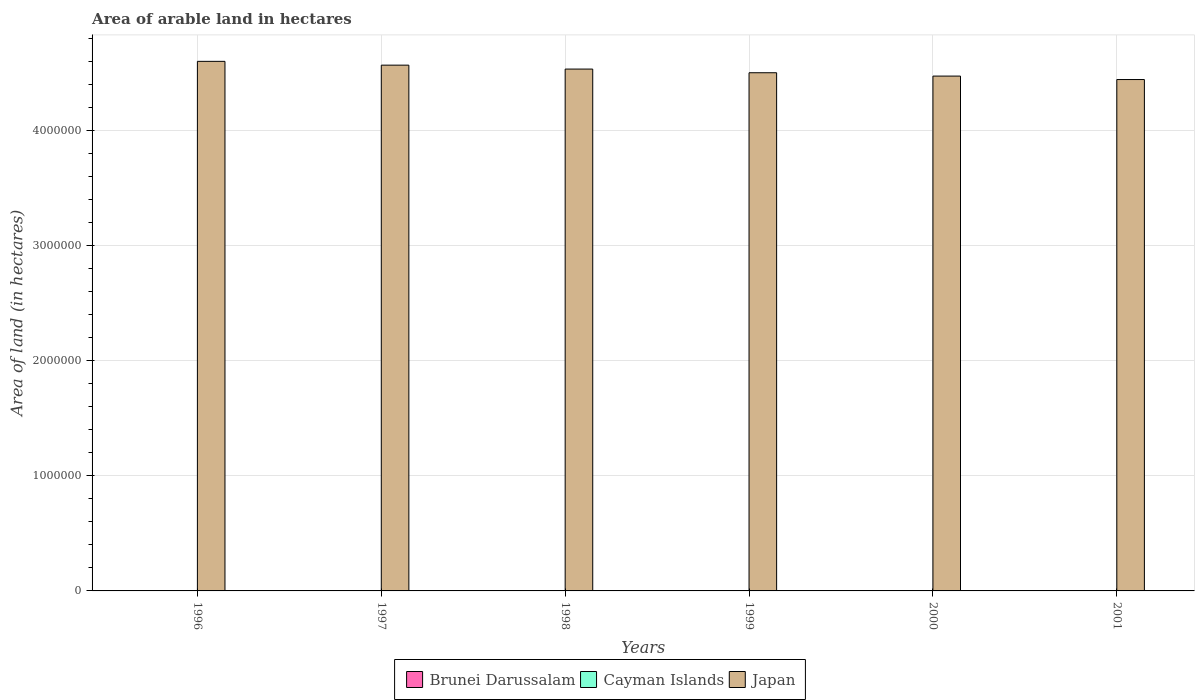How many different coloured bars are there?
Offer a very short reply. 3. How many bars are there on the 5th tick from the left?
Your response must be concise. 3. What is the total arable land in Cayman Islands in 2001?
Ensure brevity in your answer.  200. Across all years, what is the minimum total arable land in Brunei Darussalam?
Your response must be concise. 2000. What is the total total arable land in Cayman Islands in the graph?
Offer a very short reply. 1200. What is the difference between the total arable land in Brunei Darussalam in 1996 and that in 1997?
Your response must be concise. 0. What is the difference between the total arable land in Japan in 2000 and the total arable land in Cayman Islands in 1998?
Provide a succinct answer. 4.47e+06. In the year 1998, what is the difference between the total arable land in Japan and total arable land in Cayman Islands?
Offer a terse response. 4.53e+06. Is the total arable land in Brunei Darussalam in 1999 less than that in 2000?
Provide a short and direct response. No. What is the difference between the highest and the second highest total arable land in Cayman Islands?
Offer a very short reply. 0. What is the difference between the highest and the lowest total arable land in Japan?
Offer a very short reply. 1.58e+05. In how many years, is the total arable land in Brunei Darussalam greater than the average total arable land in Brunei Darussalam taken over all years?
Provide a short and direct response. 0. Is the sum of the total arable land in Brunei Darussalam in 1996 and 1997 greater than the maximum total arable land in Japan across all years?
Provide a short and direct response. No. What does the 1st bar from the left in 1998 represents?
Your answer should be compact. Brunei Darussalam. What does the 3rd bar from the right in 2001 represents?
Your response must be concise. Brunei Darussalam. Is it the case that in every year, the sum of the total arable land in Cayman Islands and total arable land in Brunei Darussalam is greater than the total arable land in Japan?
Keep it short and to the point. No. How many bars are there?
Your answer should be very brief. 18. What is the difference between two consecutive major ticks on the Y-axis?
Your answer should be compact. 1.00e+06. Does the graph contain any zero values?
Give a very brief answer. No. Does the graph contain grids?
Provide a succinct answer. Yes. Where does the legend appear in the graph?
Make the answer very short. Bottom center. How many legend labels are there?
Ensure brevity in your answer.  3. How are the legend labels stacked?
Your answer should be very brief. Horizontal. What is the title of the graph?
Your response must be concise. Area of arable land in hectares. What is the label or title of the X-axis?
Provide a succinct answer. Years. What is the label or title of the Y-axis?
Offer a terse response. Area of land (in hectares). What is the Area of land (in hectares) in Cayman Islands in 1996?
Make the answer very short. 200. What is the Area of land (in hectares) in Japan in 1996?
Offer a terse response. 4.60e+06. What is the Area of land (in hectares) of Brunei Darussalam in 1997?
Give a very brief answer. 2000. What is the Area of land (in hectares) of Cayman Islands in 1997?
Offer a terse response. 200. What is the Area of land (in hectares) of Japan in 1997?
Your response must be concise. 4.57e+06. What is the Area of land (in hectares) of Cayman Islands in 1998?
Offer a terse response. 200. What is the Area of land (in hectares) of Japan in 1998?
Your answer should be compact. 4.54e+06. What is the Area of land (in hectares) in Japan in 1999?
Offer a terse response. 4.50e+06. What is the Area of land (in hectares) in Cayman Islands in 2000?
Your answer should be compact. 200. What is the Area of land (in hectares) of Japan in 2000?
Ensure brevity in your answer.  4.47e+06. What is the Area of land (in hectares) of Brunei Darussalam in 2001?
Provide a succinct answer. 2000. What is the Area of land (in hectares) of Japan in 2001?
Your response must be concise. 4.44e+06. Across all years, what is the maximum Area of land (in hectares) in Brunei Darussalam?
Offer a terse response. 2000. Across all years, what is the maximum Area of land (in hectares) in Japan?
Offer a terse response. 4.60e+06. Across all years, what is the minimum Area of land (in hectares) in Brunei Darussalam?
Provide a succinct answer. 2000. Across all years, what is the minimum Area of land (in hectares) of Japan?
Your answer should be very brief. 4.44e+06. What is the total Area of land (in hectares) of Brunei Darussalam in the graph?
Make the answer very short. 1.20e+04. What is the total Area of land (in hectares) in Cayman Islands in the graph?
Provide a short and direct response. 1200. What is the total Area of land (in hectares) of Japan in the graph?
Keep it short and to the point. 2.71e+07. What is the difference between the Area of land (in hectares) of Japan in 1996 and that in 1997?
Your response must be concise. 3.30e+04. What is the difference between the Area of land (in hectares) in Japan in 1996 and that in 1998?
Provide a short and direct response. 6.70e+04. What is the difference between the Area of land (in hectares) of Brunei Darussalam in 1996 and that in 1999?
Offer a very short reply. 0. What is the difference between the Area of land (in hectares) of Japan in 1996 and that in 1999?
Give a very brief answer. 9.90e+04. What is the difference between the Area of land (in hectares) in Brunei Darussalam in 1996 and that in 2000?
Keep it short and to the point. 0. What is the difference between the Area of land (in hectares) of Cayman Islands in 1996 and that in 2000?
Make the answer very short. 0. What is the difference between the Area of land (in hectares) of Japan in 1996 and that in 2000?
Your answer should be very brief. 1.28e+05. What is the difference between the Area of land (in hectares) in Brunei Darussalam in 1996 and that in 2001?
Keep it short and to the point. 0. What is the difference between the Area of land (in hectares) in Japan in 1996 and that in 2001?
Provide a short and direct response. 1.58e+05. What is the difference between the Area of land (in hectares) of Japan in 1997 and that in 1998?
Give a very brief answer. 3.40e+04. What is the difference between the Area of land (in hectares) in Japan in 1997 and that in 1999?
Offer a very short reply. 6.60e+04. What is the difference between the Area of land (in hectares) in Brunei Darussalam in 1997 and that in 2000?
Keep it short and to the point. 0. What is the difference between the Area of land (in hectares) in Japan in 1997 and that in 2000?
Your answer should be compact. 9.50e+04. What is the difference between the Area of land (in hectares) of Brunei Darussalam in 1997 and that in 2001?
Your answer should be compact. 0. What is the difference between the Area of land (in hectares) in Japan in 1997 and that in 2001?
Provide a succinct answer. 1.25e+05. What is the difference between the Area of land (in hectares) of Japan in 1998 and that in 1999?
Your response must be concise. 3.20e+04. What is the difference between the Area of land (in hectares) in Cayman Islands in 1998 and that in 2000?
Your response must be concise. 0. What is the difference between the Area of land (in hectares) of Japan in 1998 and that in 2000?
Your answer should be very brief. 6.10e+04. What is the difference between the Area of land (in hectares) in Brunei Darussalam in 1998 and that in 2001?
Ensure brevity in your answer.  0. What is the difference between the Area of land (in hectares) in Cayman Islands in 1998 and that in 2001?
Your response must be concise. 0. What is the difference between the Area of land (in hectares) in Japan in 1998 and that in 2001?
Offer a very short reply. 9.10e+04. What is the difference between the Area of land (in hectares) in Brunei Darussalam in 1999 and that in 2000?
Give a very brief answer. 0. What is the difference between the Area of land (in hectares) in Cayman Islands in 1999 and that in 2000?
Your response must be concise. 0. What is the difference between the Area of land (in hectares) in Japan in 1999 and that in 2000?
Make the answer very short. 2.90e+04. What is the difference between the Area of land (in hectares) in Cayman Islands in 1999 and that in 2001?
Your answer should be compact. 0. What is the difference between the Area of land (in hectares) of Japan in 1999 and that in 2001?
Provide a succinct answer. 5.90e+04. What is the difference between the Area of land (in hectares) in Brunei Darussalam in 2000 and that in 2001?
Your answer should be very brief. 0. What is the difference between the Area of land (in hectares) of Brunei Darussalam in 1996 and the Area of land (in hectares) of Cayman Islands in 1997?
Provide a short and direct response. 1800. What is the difference between the Area of land (in hectares) of Brunei Darussalam in 1996 and the Area of land (in hectares) of Japan in 1997?
Offer a terse response. -4.57e+06. What is the difference between the Area of land (in hectares) of Cayman Islands in 1996 and the Area of land (in hectares) of Japan in 1997?
Provide a short and direct response. -4.57e+06. What is the difference between the Area of land (in hectares) in Brunei Darussalam in 1996 and the Area of land (in hectares) in Cayman Islands in 1998?
Your response must be concise. 1800. What is the difference between the Area of land (in hectares) of Brunei Darussalam in 1996 and the Area of land (in hectares) of Japan in 1998?
Keep it short and to the point. -4.53e+06. What is the difference between the Area of land (in hectares) of Cayman Islands in 1996 and the Area of land (in hectares) of Japan in 1998?
Offer a very short reply. -4.53e+06. What is the difference between the Area of land (in hectares) in Brunei Darussalam in 1996 and the Area of land (in hectares) in Cayman Islands in 1999?
Keep it short and to the point. 1800. What is the difference between the Area of land (in hectares) in Brunei Darussalam in 1996 and the Area of land (in hectares) in Japan in 1999?
Your answer should be compact. -4.50e+06. What is the difference between the Area of land (in hectares) in Cayman Islands in 1996 and the Area of land (in hectares) in Japan in 1999?
Provide a succinct answer. -4.50e+06. What is the difference between the Area of land (in hectares) of Brunei Darussalam in 1996 and the Area of land (in hectares) of Cayman Islands in 2000?
Ensure brevity in your answer.  1800. What is the difference between the Area of land (in hectares) of Brunei Darussalam in 1996 and the Area of land (in hectares) of Japan in 2000?
Offer a very short reply. -4.47e+06. What is the difference between the Area of land (in hectares) in Cayman Islands in 1996 and the Area of land (in hectares) in Japan in 2000?
Your response must be concise. -4.47e+06. What is the difference between the Area of land (in hectares) in Brunei Darussalam in 1996 and the Area of land (in hectares) in Cayman Islands in 2001?
Provide a succinct answer. 1800. What is the difference between the Area of land (in hectares) in Brunei Darussalam in 1996 and the Area of land (in hectares) in Japan in 2001?
Provide a short and direct response. -4.44e+06. What is the difference between the Area of land (in hectares) in Cayman Islands in 1996 and the Area of land (in hectares) in Japan in 2001?
Ensure brevity in your answer.  -4.44e+06. What is the difference between the Area of land (in hectares) in Brunei Darussalam in 1997 and the Area of land (in hectares) in Cayman Islands in 1998?
Give a very brief answer. 1800. What is the difference between the Area of land (in hectares) of Brunei Darussalam in 1997 and the Area of land (in hectares) of Japan in 1998?
Your answer should be very brief. -4.53e+06. What is the difference between the Area of land (in hectares) of Cayman Islands in 1997 and the Area of land (in hectares) of Japan in 1998?
Provide a succinct answer. -4.53e+06. What is the difference between the Area of land (in hectares) of Brunei Darussalam in 1997 and the Area of land (in hectares) of Cayman Islands in 1999?
Keep it short and to the point. 1800. What is the difference between the Area of land (in hectares) of Brunei Darussalam in 1997 and the Area of land (in hectares) of Japan in 1999?
Offer a terse response. -4.50e+06. What is the difference between the Area of land (in hectares) of Cayman Islands in 1997 and the Area of land (in hectares) of Japan in 1999?
Make the answer very short. -4.50e+06. What is the difference between the Area of land (in hectares) of Brunei Darussalam in 1997 and the Area of land (in hectares) of Cayman Islands in 2000?
Offer a terse response. 1800. What is the difference between the Area of land (in hectares) of Brunei Darussalam in 1997 and the Area of land (in hectares) of Japan in 2000?
Your response must be concise. -4.47e+06. What is the difference between the Area of land (in hectares) of Cayman Islands in 1997 and the Area of land (in hectares) of Japan in 2000?
Keep it short and to the point. -4.47e+06. What is the difference between the Area of land (in hectares) of Brunei Darussalam in 1997 and the Area of land (in hectares) of Cayman Islands in 2001?
Give a very brief answer. 1800. What is the difference between the Area of land (in hectares) in Brunei Darussalam in 1997 and the Area of land (in hectares) in Japan in 2001?
Offer a terse response. -4.44e+06. What is the difference between the Area of land (in hectares) in Cayman Islands in 1997 and the Area of land (in hectares) in Japan in 2001?
Ensure brevity in your answer.  -4.44e+06. What is the difference between the Area of land (in hectares) of Brunei Darussalam in 1998 and the Area of land (in hectares) of Cayman Islands in 1999?
Give a very brief answer. 1800. What is the difference between the Area of land (in hectares) of Brunei Darussalam in 1998 and the Area of land (in hectares) of Japan in 1999?
Offer a terse response. -4.50e+06. What is the difference between the Area of land (in hectares) of Cayman Islands in 1998 and the Area of land (in hectares) of Japan in 1999?
Keep it short and to the point. -4.50e+06. What is the difference between the Area of land (in hectares) in Brunei Darussalam in 1998 and the Area of land (in hectares) in Cayman Islands in 2000?
Provide a succinct answer. 1800. What is the difference between the Area of land (in hectares) of Brunei Darussalam in 1998 and the Area of land (in hectares) of Japan in 2000?
Give a very brief answer. -4.47e+06. What is the difference between the Area of land (in hectares) in Cayman Islands in 1998 and the Area of land (in hectares) in Japan in 2000?
Your answer should be very brief. -4.47e+06. What is the difference between the Area of land (in hectares) in Brunei Darussalam in 1998 and the Area of land (in hectares) in Cayman Islands in 2001?
Your answer should be compact. 1800. What is the difference between the Area of land (in hectares) in Brunei Darussalam in 1998 and the Area of land (in hectares) in Japan in 2001?
Provide a short and direct response. -4.44e+06. What is the difference between the Area of land (in hectares) in Cayman Islands in 1998 and the Area of land (in hectares) in Japan in 2001?
Give a very brief answer. -4.44e+06. What is the difference between the Area of land (in hectares) in Brunei Darussalam in 1999 and the Area of land (in hectares) in Cayman Islands in 2000?
Offer a very short reply. 1800. What is the difference between the Area of land (in hectares) in Brunei Darussalam in 1999 and the Area of land (in hectares) in Japan in 2000?
Give a very brief answer. -4.47e+06. What is the difference between the Area of land (in hectares) of Cayman Islands in 1999 and the Area of land (in hectares) of Japan in 2000?
Your answer should be compact. -4.47e+06. What is the difference between the Area of land (in hectares) in Brunei Darussalam in 1999 and the Area of land (in hectares) in Cayman Islands in 2001?
Give a very brief answer. 1800. What is the difference between the Area of land (in hectares) in Brunei Darussalam in 1999 and the Area of land (in hectares) in Japan in 2001?
Give a very brief answer. -4.44e+06. What is the difference between the Area of land (in hectares) of Cayman Islands in 1999 and the Area of land (in hectares) of Japan in 2001?
Give a very brief answer. -4.44e+06. What is the difference between the Area of land (in hectares) in Brunei Darussalam in 2000 and the Area of land (in hectares) in Cayman Islands in 2001?
Offer a terse response. 1800. What is the difference between the Area of land (in hectares) of Brunei Darussalam in 2000 and the Area of land (in hectares) of Japan in 2001?
Make the answer very short. -4.44e+06. What is the difference between the Area of land (in hectares) in Cayman Islands in 2000 and the Area of land (in hectares) in Japan in 2001?
Provide a short and direct response. -4.44e+06. What is the average Area of land (in hectares) in Brunei Darussalam per year?
Give a very brief answer. 2000. What is the average Area of land (in hectares) in Cayman Islands per year?
Provide a short and direct response. 200. What is the average Area of land (in hectares) in Japan per year?
Provide a succinct answer. 4.52e+06. In the year 1996, what is the difference between the Area of land (in hectares) in Brunei Darussalam and Area of land (in hectares) in Cayman Islands?
Give a very brief answer. 1800. In the year 1996, what is the difference between the Area of land (in hectares) in Brunei Darussalam and Area of land (in hectares) in Japan?
Your response must be concise. -4.60e+06. In the year 1996, what is the difference between the Area of land (in hectares) in Cayman Islands and Area of land (in hectares) in Japan?
Offer a very short reply. -4.60e+06. In the year 1997, what is the difference between the Area of land (in hectares) in Brunei Darussalam and Area of land (in hectares) in Cayman Islands?
Your response must be concise. 1800. In the year 1997, what is the difference between the Area of land (in hectares) of Brunei Darussalam and Area of land (in hectares) of Japan?
Your answer should be compact. -4.57e+06. In the year 1997, what is the difference between the Area of land (in hectares) of Cayman Islands and Area of land (in hectares) of Japan?
Offer a terse response. -4.57e+06. In the year 1998, what is the difference between the Area of land (in hectares) in Brunei Darussalam and Area of land (in hectares) in Cayman Islands?
Keep it short and to the point. 1800. In the year 1998, what is the difference between the Area of land (in hectares) of Brunei Darussalam and Area of land (in hectares) of Japan?
Offer a very short reply. -4.53e+06. In the year 1998, what is the difference between the Area of land (in hectares) of Cayman Islands and Area of land (in hectares) of Japan?
Make the answer very short. -4.53e+06. In the year 1999, what is the difference between the Area of land (in hectares) in Brunei Darussalam and Area of land (in hectares) in Cayman Islands?
Offer a very short reply. 1800. In the year 1999, what is the difference between the Area of land (in hectares) in Brunei Darussalam and Area of land (in hectares) in Japan?
Your answer should be very brief. -4.50e+06. In the year 1999, what is the difference between the Area of land (in hectares) in Cayman Islands and Area of land (in hectares) in Japan?
Make the answer very short. -4.50e+06. In the year 2000, what is the difference between the Area of land (in hectares) in Brunei Darussalam and Area of land (in hectares) in Cayman Islands?
Offer a terse response. 1800. In the year 2000, what is the difference between the Area of land (in hectares) of Brunei Darussalam and Area of land (in hectares) of Japan?
Make the answer very short. -4.47e+06. In the year 2000, what is the difference between the Area of land (in hectares) in Cayman Islands and Area of land (in hectares) in Japan?
Your answer should be compact. -4.47e+06. In the year 2001, what is the difference between the Area of land (in hectares) of Brunei Darussalam and Area of land (in hectares) of Cayman Islands?
Your answer should be very brief. 1800. In the year 2001, what is the difference between the Area of land (in hectares) of Brunei Darussalam and Area of land (in hectares) of Japan?
Your answer should be very brief. -4.44e+06. In the year 2001, what is the difference between the Area of land (in hectares) in Cayman Islands and Area of land (in hectares) in Japan?
Make the answer very short. -4.44e+06. What is the ratio of the Area of land (in hectares) in Brunei Darussalam in 1996 to that in 1998?
Your response must be concise. 1. What is the ratio of the Area of land (in hectares) of Cayman Islands in 1996 to that in 1998?
Make the answer very short. 1. What is the ratio of the Area of land (in hectares) in Japan in 1996 to that in 1998?
Your answer should be compact. 1.01. What is the ratio of the Area of land (in hectares) of Brunei Darussalam in 1996 to that in 1999?
Provide a succinct answer. 1. What is the ratio of the Area of land (in hectares) in Cayman Islands in 1996 to that in 1999?
Offer a very short reply. 1. What is the ratio of the Area of land (in hectares) of Japan in 1996 to that in 1999?
Your answer should be very brief. 1.02. What is the ratio of the Area of land (in hectares) in Japan in 1996 to that in 2000?
Offer a very short reply. 1.03. What is the ratio of the Area of land (in hectares) in Brunei Darussalam in 1996 to that in 2001?
Provide a succinct answer. 1. What is the ratio of the Area of land (in hectares) of Japan in 1996 to that in 2001?
Provide a short and direct response. 1.04. What is the ratio of the Area of land (in hectares) of Cayman Islands in 1997 to that in 1998?
Your answer should be very brief. 1. What is the ratio of the Area of land (in hectares) of Japan in 1997 to that in 1998?
Make the answer very short. 1.01. What is the ratio of the Area of land (in hectares) in Japan in 1997 to that in 1999?
Provide a short and direct response. 1.01. What is the ratio of the Area of land (in hectares) of Brunei Darussalam in 1997 to that in 2000?
Ensure brevity in your answer.  1. What is the ratio of the Area of land (in hectares) in Cayman Islands in 1997 to that in 2000?
Ensure brevity in your answer.  1. What is the ratio of the Area of land (in hectares) in Japan in 1997 to that in 2000?
Keep it short and to the point. 1.02. What is the ratio of the Area of land (in hectares) of Cayman Islands in 1997 to that in 2001?
Provide a succinct answer. 1. What is the ratio of the Area of land (in hectares) of Japan in 1997 to that in 2001?
Provide a short and direct response. 1.03. What is the ratio of the Area of land (in hectares) of Brunei Darussalam in 1998 to that in 1999?
Your answer should be compact. 1. What is the ratio of the Area of land (in hectares) of Cayman Islands in 1998 to that in 1999?
Offer a very short reply. 1. What is the ratio of the Area of land (in hectares) of Japan in 1998 to that in 1999?
Ensure brevity in your answer.  1.01. What is the ratio of the Area of land (in hectares) of Japan in 1998 to that in 2000?
Provide a short and direct response. 1.01. What is the ratio of the Area of land (in hectares) of Cayman Islands in 1998 to that in 2001?
Keep it short and to the point. 1. What is the ratio of the Area of land (in hectares) of Japan in 1998 to that in 2001?
Provide a succinct answer. 1.02. What is the ratio of the Area of land (in hectares) of Cayman Islands in 1999 to that in 2000?
Make the answer very short. 1. What is the ratio of the Area of land (in hectares) of Cayman Islands in 1999 to that in 2001?
Your response must be concise. 1. What is the ratio of the Area of land (in hectares) of Japan in 1999 to that in 2001?
Provide a succinct answer. 1.01. What is the ratio of the Area of land (in hectares) in Cayman Islands in 2000 to that in 2001?
Ensure brevity in your answer.  1. What is the ratio of the Area of land (in hectares) of Japan in 2000 to that in 2001?
Give a very brief answer. 1.01. What is the difference between the highest and the second highest Area of land (in hectares) in Cayman Islands?
Make the answer very short. 0. What is the difference between the highest and the second highest Area of land (in hectares) of Japan?
Your answer should be compact. 3.30e+04. What is the difference between the highest and the lowest Area of land (in hectares) in Brunei Darussalam?
Ensure brevity in your answer.  0. What is the difference between the highest and the lowest Area of land (in hectares) of Japan?
Your answer should be very brief. 1.58e+05. 